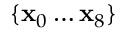Convert formula to latex. <formula><loc_0><loc_0><loc_500><loc_500>\{ x _ { 0 } \dots x _ { 8 } \}</formula> 